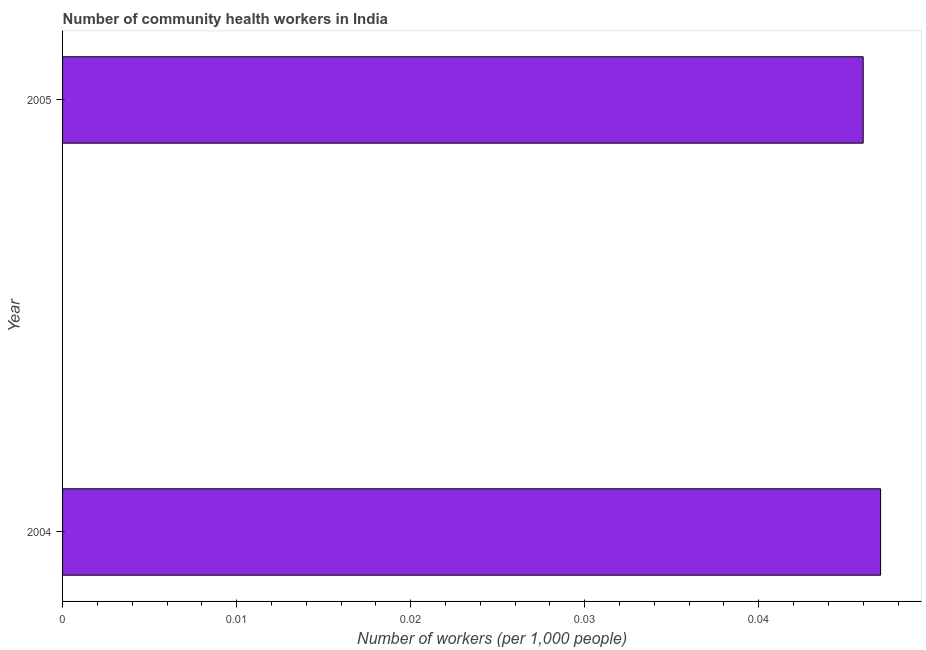Does the graph contain any zero values?
Ensure brevity in your answer.  No. Does the graph contain grids?
Provide a succinct answer. No. What is the title of the graph?
Your response must be concise. Number of community health workers in India. What is the label or title of the X-axis?
Give a very brief answer. Number of workers (per 1,0 people). What is the label or title of the Y-axis?
Offer a very short reply. Year. What is the number of community health workers in 2004?
Your response must be concise. 0.05. Across all years, what is the maximum number of community health workers?
Your answer should be compact. 0.05. Across all years, what is the minimum number of community health workers?
Offer a very short reply. 0.05. In which year was the number of community health workers minimum?
Offer a very short reply. 2005. What is the sum of the number of community health workers?
Offer a terse response. 0.09. What is the average number of community health workers per year?
Ensure brevity in your answer.  0.05. What is the median number of community health workers?
Provide a short and direct response. 0.05. Do a majority of the years between 2004 and 2005 (inclusive) have number of community health workers greater than 0.006 ?
Keep it short and to the point. Yes. What is the ratio of the number of community health workers in 2004 to that in 2005?
Provide a short and direct response. 1.02. In how many years, is the number of community health workers greater than the average number of community health workers taken over all years?
Make the answer very short. 1. Are all the bars in the graph horizontal?
Ensure brevity in your answer.  Yes. How many years are there in the graph?
Offer a very short reply. 2. Are the values on the major ticks of X-axis written in scientific E-notation?
Keep it short and to the point. No. What is the Number of workers (per 1,000 people) of 2004?
Your answer should be very brief. 0.05. What is the Number of workers (per 1,000 people) in 2005?
Keep it short and to the point. 0.05. What is the ratio of the Number of workers (per 1,000 people) in 2004 to that in 2005?
Give a very brief answer. 1.02. 